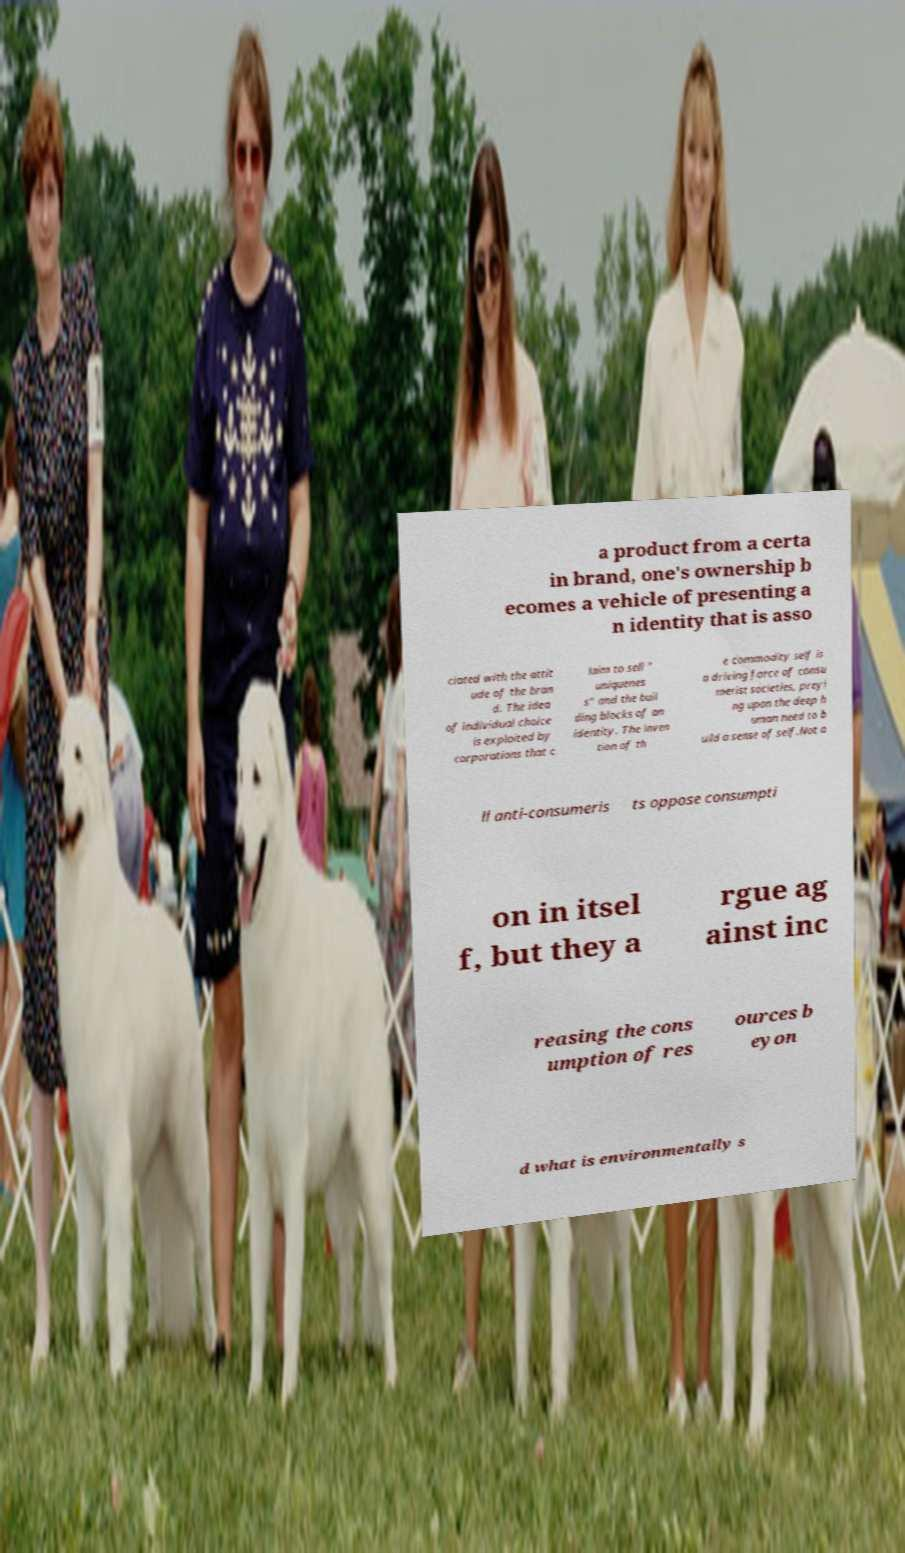Can you read and provide the text displayed in the image?This photo seems to have some interesting text. Can you extract and type it out for me? a product from a certa in brand, one's ownership b ecomes a vehicle of presenting a n identity that is asso ciated with the attit ude of the bran d. The idea of individual choice is exploited by corporations that c laim to sell " uniquenes s" and the buil ding blocks of an identity. The inven tion of th e commodity self is a driving force of consu merist societies, preyi ng upon the deep h uman need to b uild a sense of self.Not a ll anti-consumeris ts oppose consumpti on in itsel f, but they a rgue ag ainst inc reasing the cons umption of res ources b eyon d what is environmentally s 